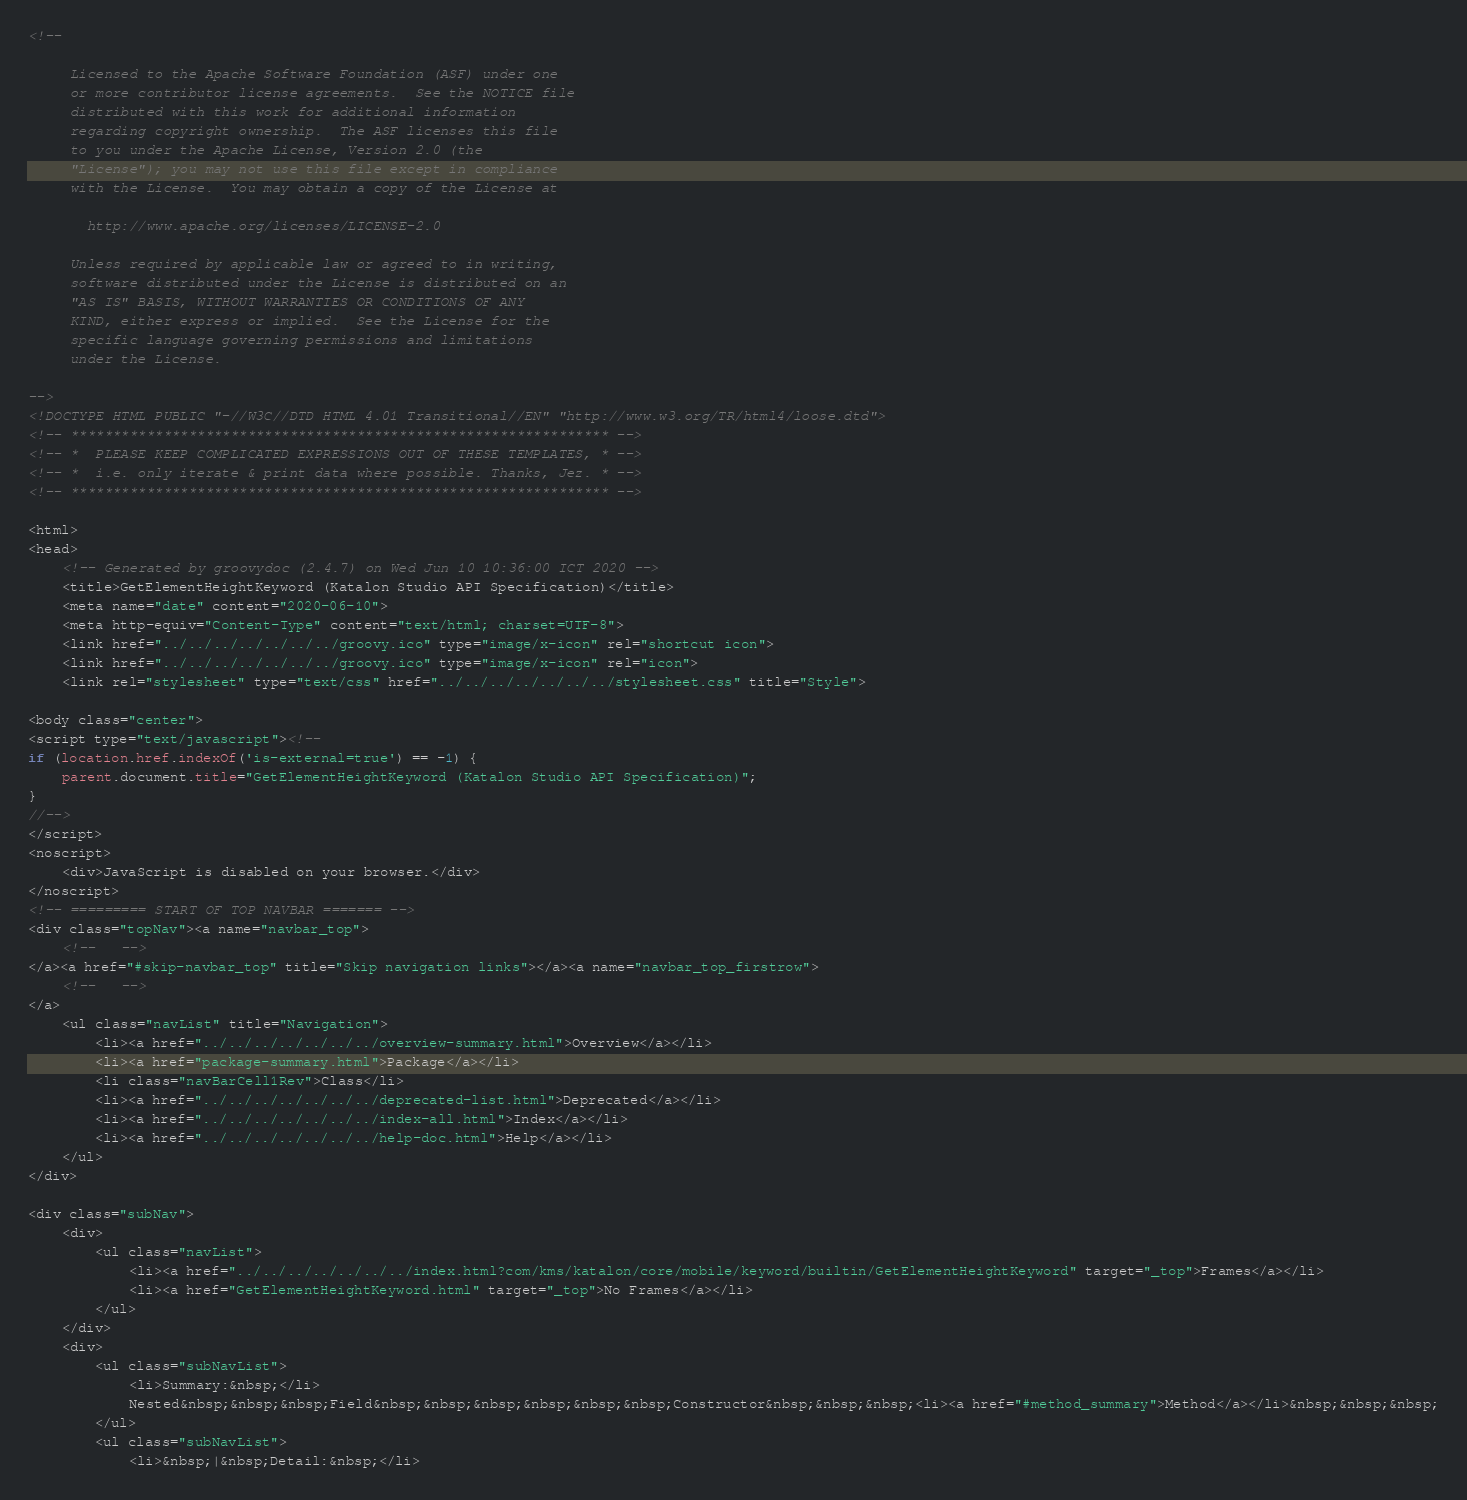Convert code to text. <code><loc_0><loc_0><loc_500><loc_500><_HTML_><!--

     Licensed to the Apache Software Foundation (ASF) under one
     or more contributor license agreements.  See the NOTICE file
     distributed with this work for additional information
     regarding copyright ownership.  The ASF licenses this file
     to you under the Apache License, Version 2.0 (the
     "License"); you may not use this file except in compliance
     with the License.  You may obtain a copy of the License at

       http://www.apache.org/licenses/LICENSE-2.0

     Unless required by applicable law or agreed to in writing,
     software distributed under the License is distributed on an
     "AS IS" BASIS, WITHOUT WARRANTIES OR CONDITIONS OF ANY
     KIND, either express or implied.  See the License for the
     specific language governing permissions and limitations
     under the License.

-->
<!DOCTYPE HTML PUBLIC "-//W3C//DTD HTML 4.01 Transitional//EN" "http://www.w3.org/TR/html4/loose.dtd">
<!-- **************************************************************** -->
<!-- *  PLEASE KEEP COMPLICATED EXPRESSIONS OUT OF THESE TEMPLATES, * -->
<!-- *  i.e. only iterate & print data where possible. Thanks, Jez. * -->
<!-- **************************************************************** -->

<html>
<head>
    <!-- Generated by groovydoc (2.4.7) on Wed Jun 10 10:36:00 ICT 2020 -->
    <title>GetElementHeightKeyword (Katalon Studio API Specification)</title>
    <meta name="date" content="2020-06-10">
    <meta http-equiv="Content-Type" content="text/html; charset=UTF-8">
    <link href="../../../../../../../groovy.ico" type="image/x-icon" rel="shortcut icon">
    <link href="../../../../../../../groovy.ico" type="image/x-icon" rel="icon">
    <link rel="stylesheet" type="text/css" href="../../../../../../../stylesheet.css" title="Style">

<body class="center">
<script type="text/javascript"><!--
if (location.href.indexOf('is-external=true') == -1) {
    parent.document.title="GetElementHeightKeyword (Katalon Studio API Specification)";
}
//-->
</script>
<noscript>
    <div>JavaScript is disabled on your browser.</div>
</noscript>
<!-- ========= START OF TOP NAVBAR ======= -->
<div class="topNav"><a name="navbar_top">
    <!--   -->
</a><a href="#skip-navbar_top" title="Skip navigation links"></a><a name="navbar_top_firstrow">
    <!--   -->
</a>
    <ul class="navList" title="Navigation">
        <li><a href="../../../../../../../overview-summary.html">Overview</a></li>
        <li><a href="package-summary.html">Package</a></li>
        <li class="navBarCell1Rev">Class</li>
        <li><a href="../../../../../../../deprecated-list.html">Deprecated</a></li>
        <li><a href="../../../../../../../index-all.html">Index</a></li>
        <li><a href="../../../../../../../help-doc.html">Help</a></li>
    </ul>
</div>

<div class="subNav">
    <div>
        <ul class="navList">
            <li><a href="../../../../../../../index.html?com/kms/katalon/core/mobile/keyword/builtin/GetElementHeightKeyword" target="_top">Frames</a></li>
            <li><a href="GetElementHeightKeyword.html" target="_top">No Frames</a></li>
        </ul>
    </div>
    <div>
        <ul class="subNavList">
            <li>Summary:&nbsp;</li>
            Nested&nbsp;&nbsp;&nbsp;Field&nbsp;&nbsp;&nbsp;&nbsp;&nbsp;&nbsp;Constructor&nbsp;&nbsp;&nbsp;<li><a href="#method_summary">Method</a></li>&nbsp;&nbsp;&nbsp;
        </ul>
        <ul class="subNavList">
            <li>&nbsp;|&nbsp;Detail:&nbsp;</li></code> 